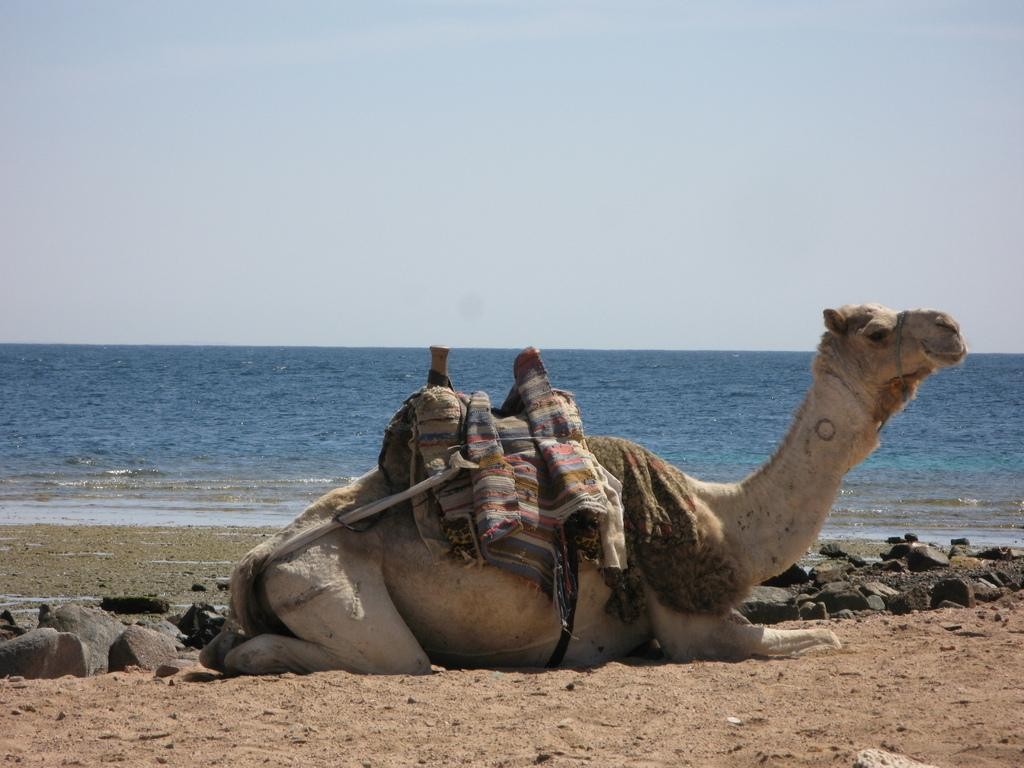What animal is sitting on the sand in the image? There is a camel sitting on the sand in the image. What type of terrain is visible in the image? The terrain is sandy, as the camel is sitting on the sand. What other objects can be seen in the image? There are stones visible in the image. What can be seen in the background of the image? There is water and the sky visible in the background of the image. What shape is the sugar cube in the image? There is no sugar cube present in the image. 